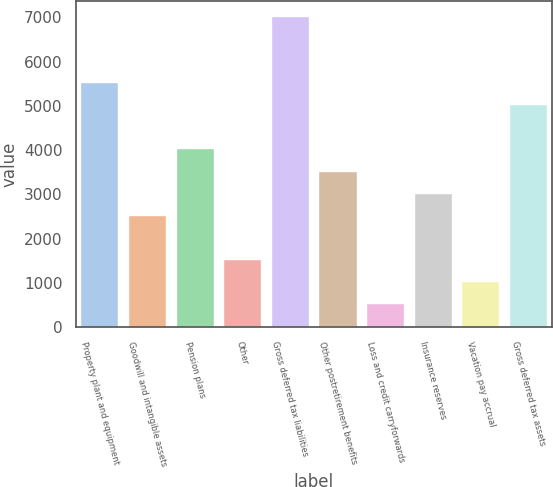Convert chart to OTSL. <chart><loc_0><loc_0><loc_500><loc_500><bar_chart><fcel>Property plant and equipment<fcel>Goodwill and intangible assets<fcel>Pension plans<fcel>Other<fcel>Gross deferred tax liabilities<fcel>Other postretirement benefits<fcel>Loss and credit carryforwards<fcel>Insurance reserves<fcel>Vacation pay accrual<fcel>Gross deferred tax assets<nl><fcel>5534.2<fcel>2545<fcel>4039.6<fcel>1548.6<fcel>7028.8<fcel>3541.4<fcel>552.2<fcel>3043.2<fcel>1050.4<fcel>5036<nl></chart> 